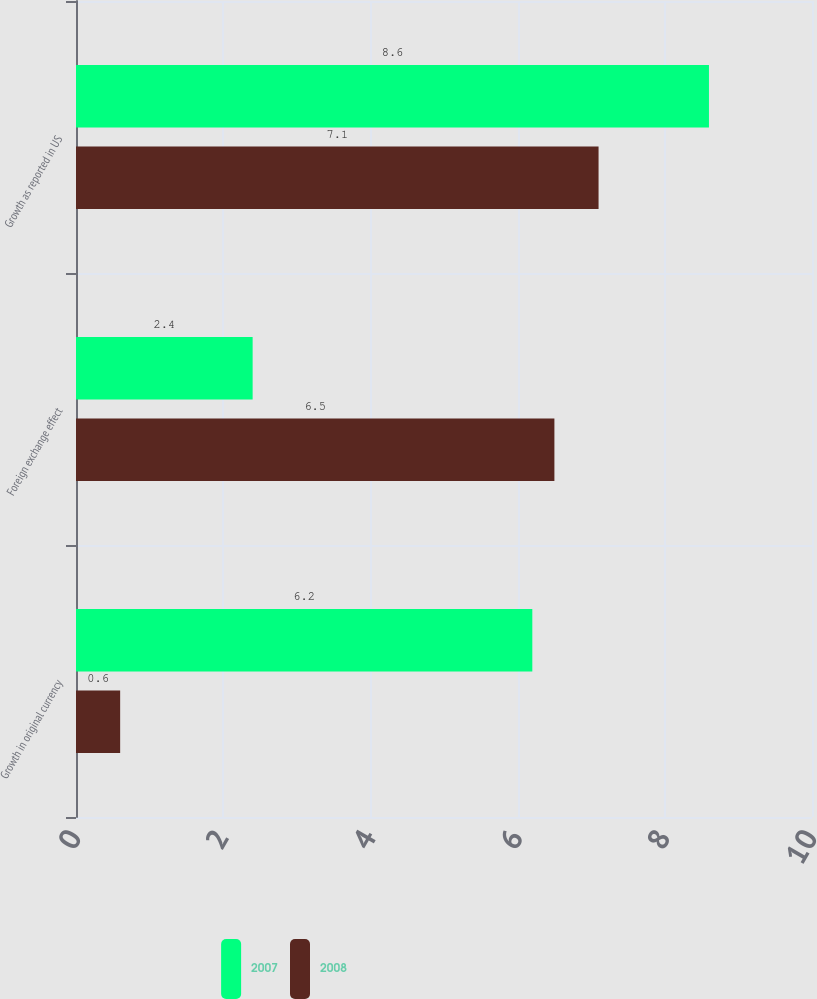<chart> <loc_0><loc_0><loc_500><loc_500><stacked_bar_chart><ecel><fcel>Growth in original currency<fcel>Foreign exchange effect<fcel>Growth as reported in US<nl><fcel>2007<fcel>6.2<fcel>2.4<fcel>8.6<nl><fcel>2008<fcel>0.6<fcel>6.5<fcel>7.1<nl></chart> 